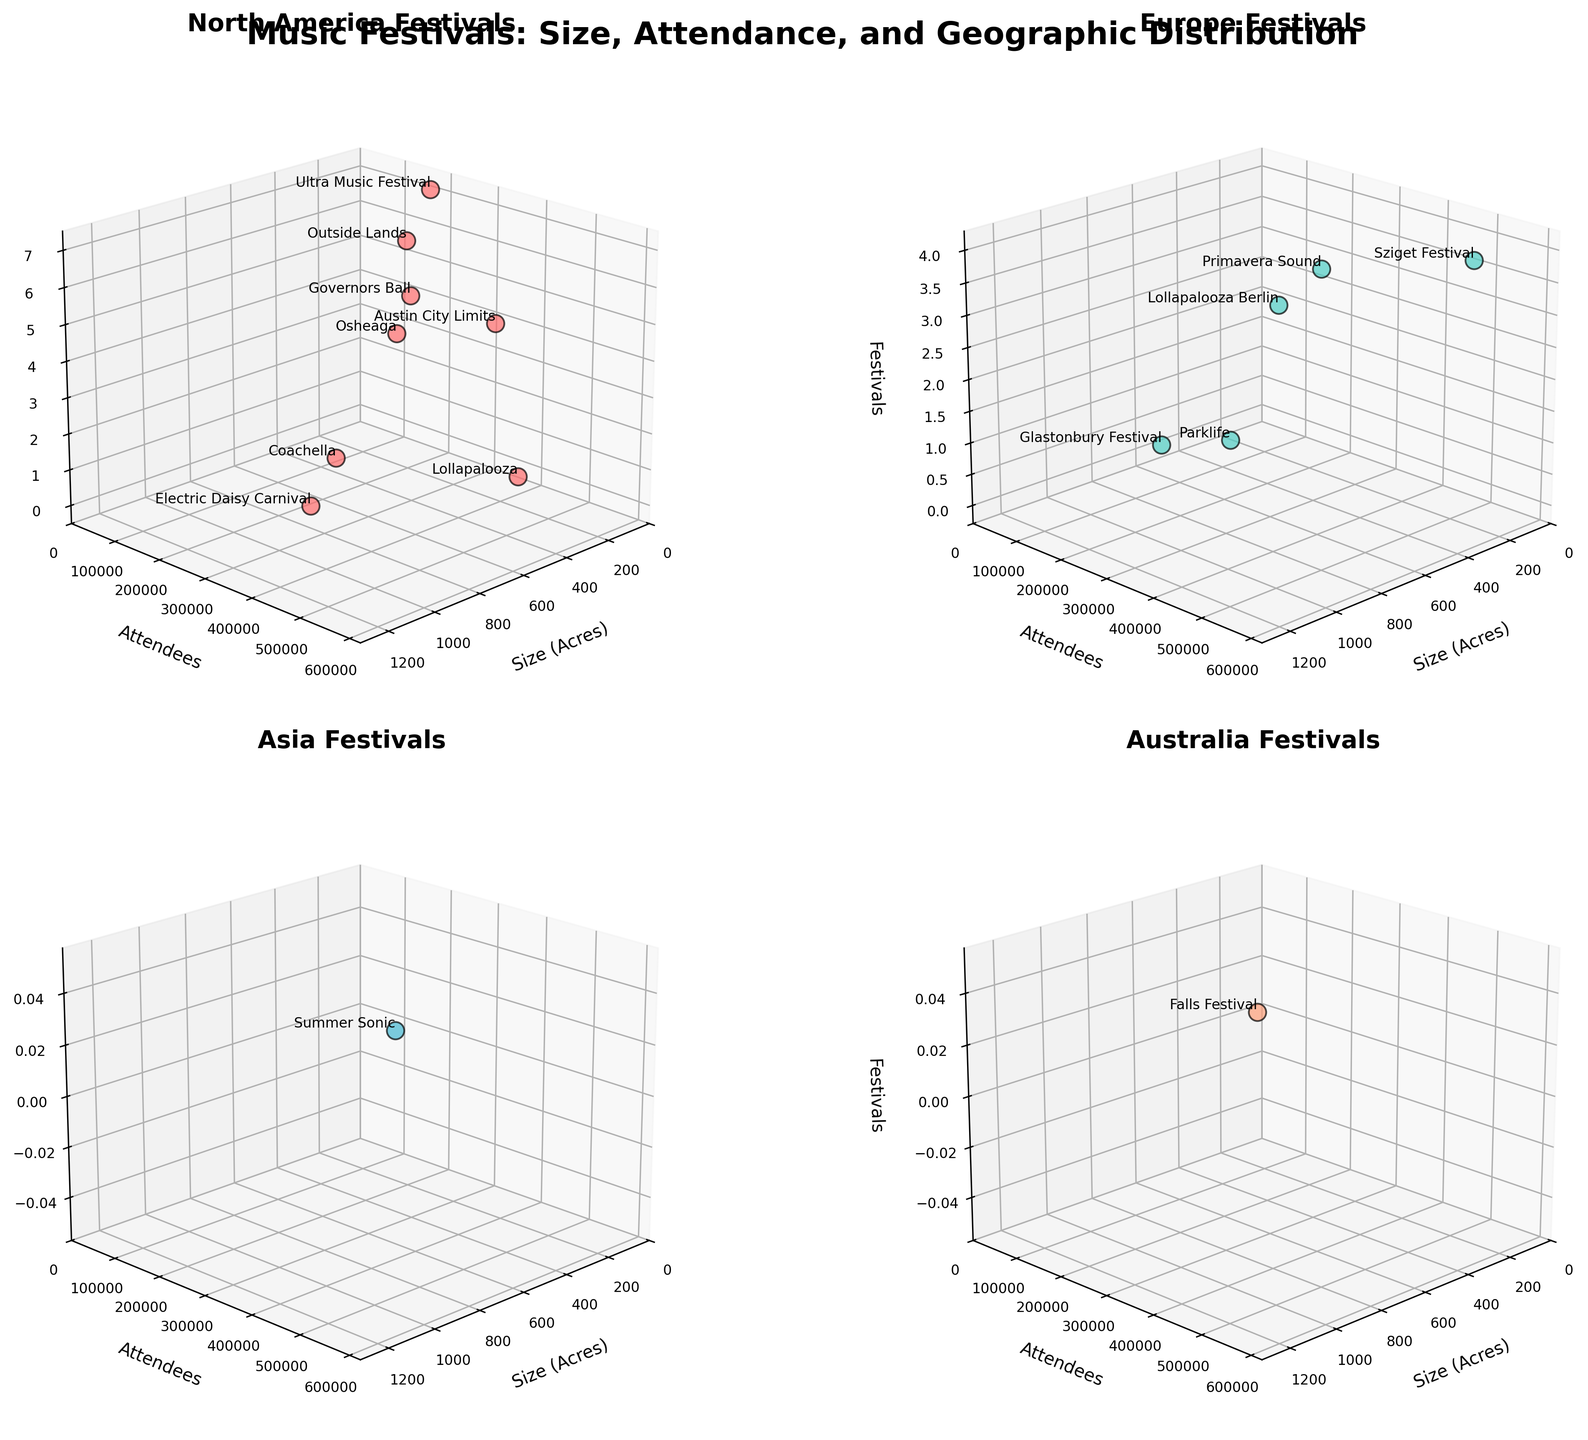What regions are represented in the subplots? The figure has subplots for North America, Europe, Asia, and Australia, as indicated by their titles.
Answer: North America, Europe, Asia, Australia Which region has the festival with the highest attendance? The subplot for Europe shows the Sziget Festival in Budapest with the highest attendance, exceeding 500,000 attendees.
Answer: Europe What is the average festival size in North America? In the North America subplot, the festivals have sizes of 115, 642, 1200, 135, 80, 350, 210, and 32 acres. Sum these to get 2764 and divide by 8 (the number of festivals) to find the average size.
Answer: 345.5 acres Which region has the least number of festivals represented? The Asia and Australia plots show just one festival each, compared to multiple festivals in North America and Europe.
Answer: Asia and Australia Which region has the festival with the minimum number of attendees? In the Australia subplot, the Falls Festival in Melbourne has the minimum number of attendees, around 25,000.
Answer: Australia How many festivals in North America have more than 200,000 attendees? The North America subplot can be checked to see that four festivals (Lollapalooza, Coachella, Austin City Limits, Electric Daisy Carnival) have over 200,000 attendees.
Answer: Four What is the correlation between festival size and number of attendees in Europe? Observing the Europe subplot, there isn't a clear linear relationship between festival size and the number of attendees. The sizes and attendees vary without a consistent pattern.
Answer: No clear correlation Compare the attendees of the largest festival in Australia and Asia. Which one is larger and by how much? The largest festival in Australia (Falls Festival, 25,000 attendees) and the largest in Asia (Summer Sonic, 135,000 attendees). The difference is 135,000 - 25,000.
Answer: Asia by 110,000 attendees What is the total attendance of music festivals in Europe represented in the figure? The Europe subplot's attendee data includes 80,000 (Parklife), 210,000 (Glastonbury), 85,000 (Lollapalooza Berlin), 220,000 (Primavera Sound), 565,000 (Sziget Festival). Adding these together sums up to 1,160,000 attendees.
Answer: 1,160,000 attendees 